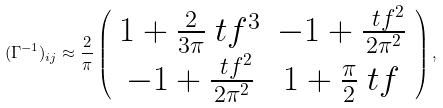<formula> <loc_0><loc_0><loc_500><loc_500>( \Gamma ^ { - 1 } ) _ { i j } \approx \frac { 2 } { \pi } \left ( \begin{array} { c c } 1 + \frac { 2 } { 3 \pi } \ t f ^ { 3 } & - 1 + \frac { \ t f ^ { 2 } } { 2 \pi ^ { 2 } } \\ - 1 + \frac { \ t f ^ { 2 } } { 2 \pi ^ { 2 } } & 1 + \frac { \pi } { 2 } \ t f \\ \end{array} \right ) ,</formula> 